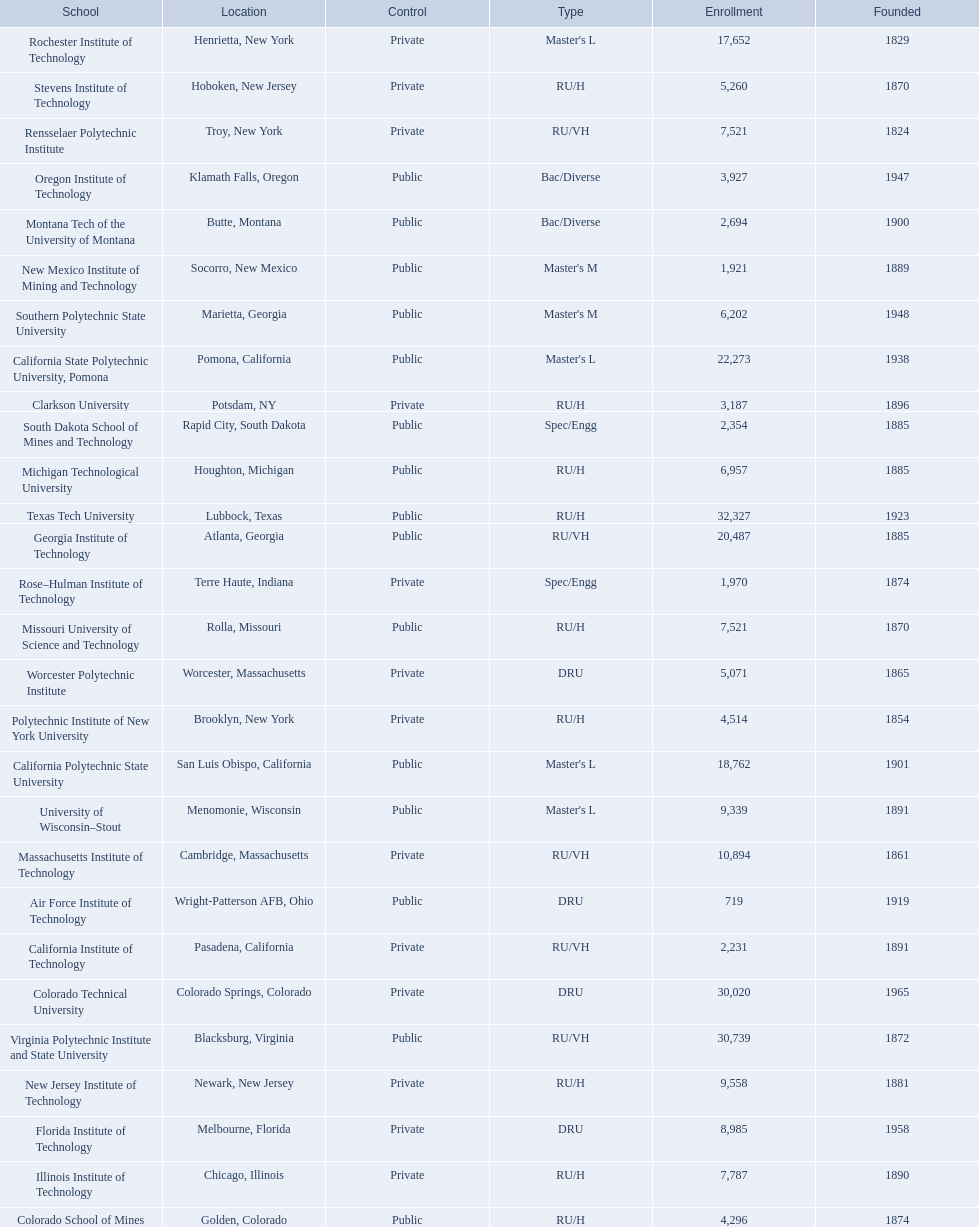What are all the schools? Air Force Institute of Technology, California Institute of Technology, California Polytechnic State University, California State Polytechnic University, Pomona, Clarkson University, Colorado School of Mines, Colorado Technical University, Florida Institute of Technology, Georgia Institute of Technology, Illinois Institute of Technology, Massachusetts Institute of Technology, Michigan Technological University, Missouri University of Science and Technology, Montana Tech of the University of Montana, New Jersey Institute of Technology, New Mexico Institute of Mining and Technology, Oregon Institute of Technology, Polytechnic Institute of New York University, Rensselaer Polytechnic Institute, Rochester Institute of Technology, Rose–Hulman Institute of Technology, South Dakota School of Mines and Technology, Southern Polytechnic State University, Stevens Institute of Technology, Texas Tech University, University of Wisconsin–Stout, Virginia Polytechnic Institute and State University, Worcester Polytechnic Institute. What is the enrollment of each school? 719, 2,231, 18,762, 22,273, 3,187, 4,296, 30,020, 8,985, 20,487, 7,787, 10,894, 6,957, 7,521, 2,694, 9,558, 1,921, 3,927, 4,514, 7,521, 17,652, 1,970, 2,354, 6,202, 5,260, 32,327, 9,339, 30,739, 5,071. And which school had the highest enrollment? Texas Tech University. 